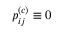Convert formula to latex. <formula><loc_0><loc_0><loc_500><loc_500>p _ { i j } ^ { ( c ) } \equiv 0</formula> 